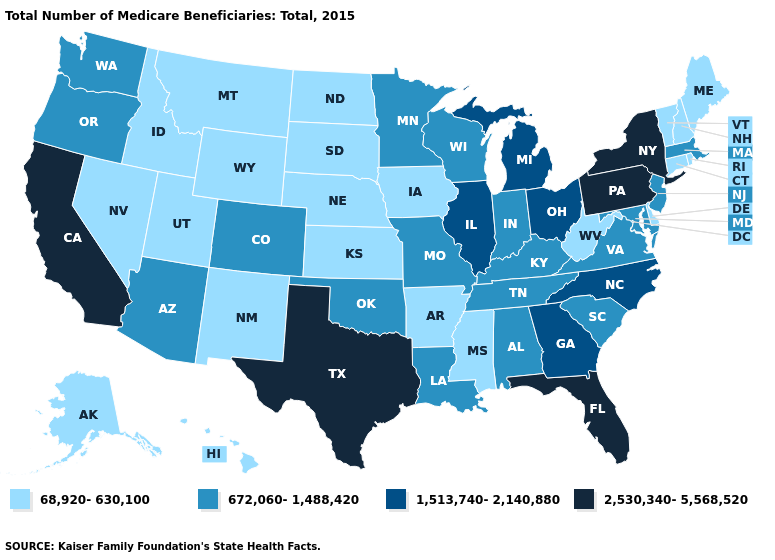Does Colorado have a higher value than Oklahoma?
Be succinct. No. What is the value of Arkansas?
Keep it brief. 68,920-630,100. What is the value of Rhode Island?
Give a very brief answer. 68,920-630,100. Does Idaho have the same value as Georgia?
Answer briefly. No. What is the highest value in the USA?
Quick response, please. 2,530,340-5,568,520. Does West Virginia have the same value as Indiana?
Concise answer only. No. What is the value of Arizona?
Write a very short answer. 672,060-1,488,420. Does Michigan have the highest value in the MidWest?
Be succinct. Yes. What is the value of Maine?
Give a very brief answer. 68,920-630,100. What is the value of Alabama?
Quick response, please. 672,060-1,488,420. Does Wyoming have the highest value in the West?
Give a very brief answer. No. What is the value of Missouri?
Give a very brief answer. 672,060-1,488,420. Name the states that have a value in the range 2,530,340-5,568,520?
Give a very brief answer. California, Florida, New York, Pennsylvania, Texas. Does Alaska have the same value as South Dakota?
Keep it brief. Yes. 